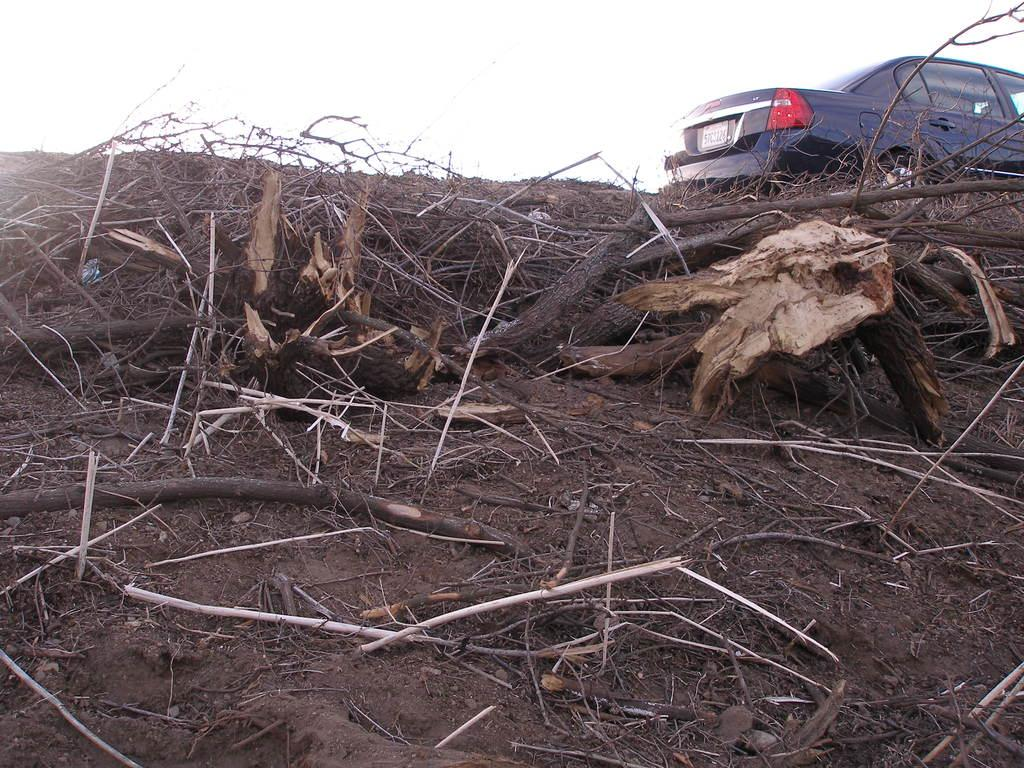What objects are on the land in the image? There are wooden sticks on the land in the image. Where are the wooden sticks located in the image? The wooden sticks are in the middle of the image. What can be seen on the right side of the image? There is a car on the right side of the image. What type of locket is hanging from the wooden sticks in the image? There is no locket present in the image; it features wooden sticks and a car. What is the frame of the image made of? The frame of the image is not visible in the provided facts, so it cannot be determined. 